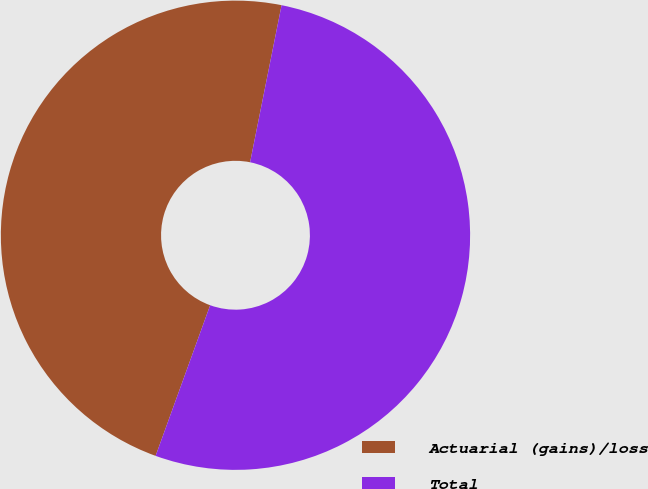Convert chart to OTSL. <chart><loc_0><loc_0><loc_500><loc_500><pie_chart><fcel>Actuarial (gains)/loss<fcel>Total<nl><fcel>47.62%<fcel>52.38%<nl></chart> 